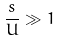<formula> <loc_0><loc_0><loc_500><loc_500>\frac { s } { U } \gg 1</formula> 